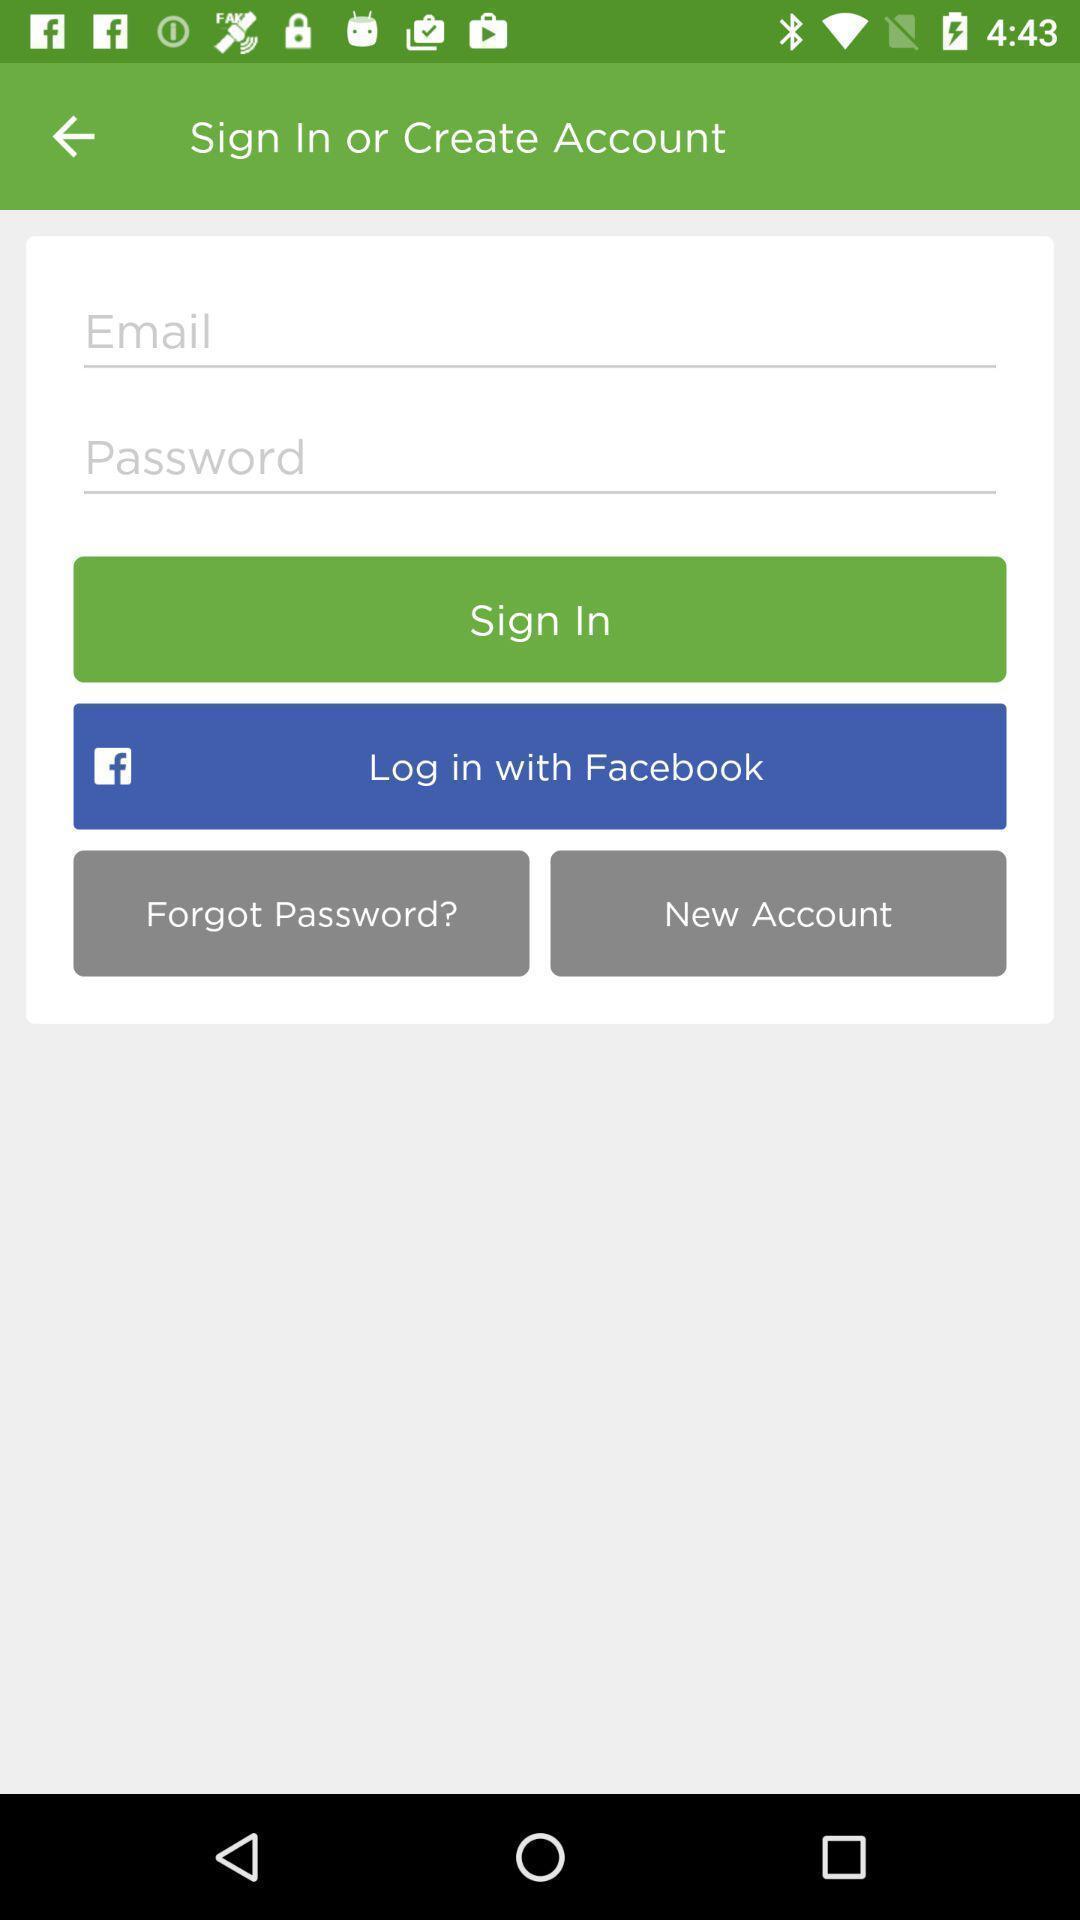Please provide a description for this image. Sign in page of a social app. 